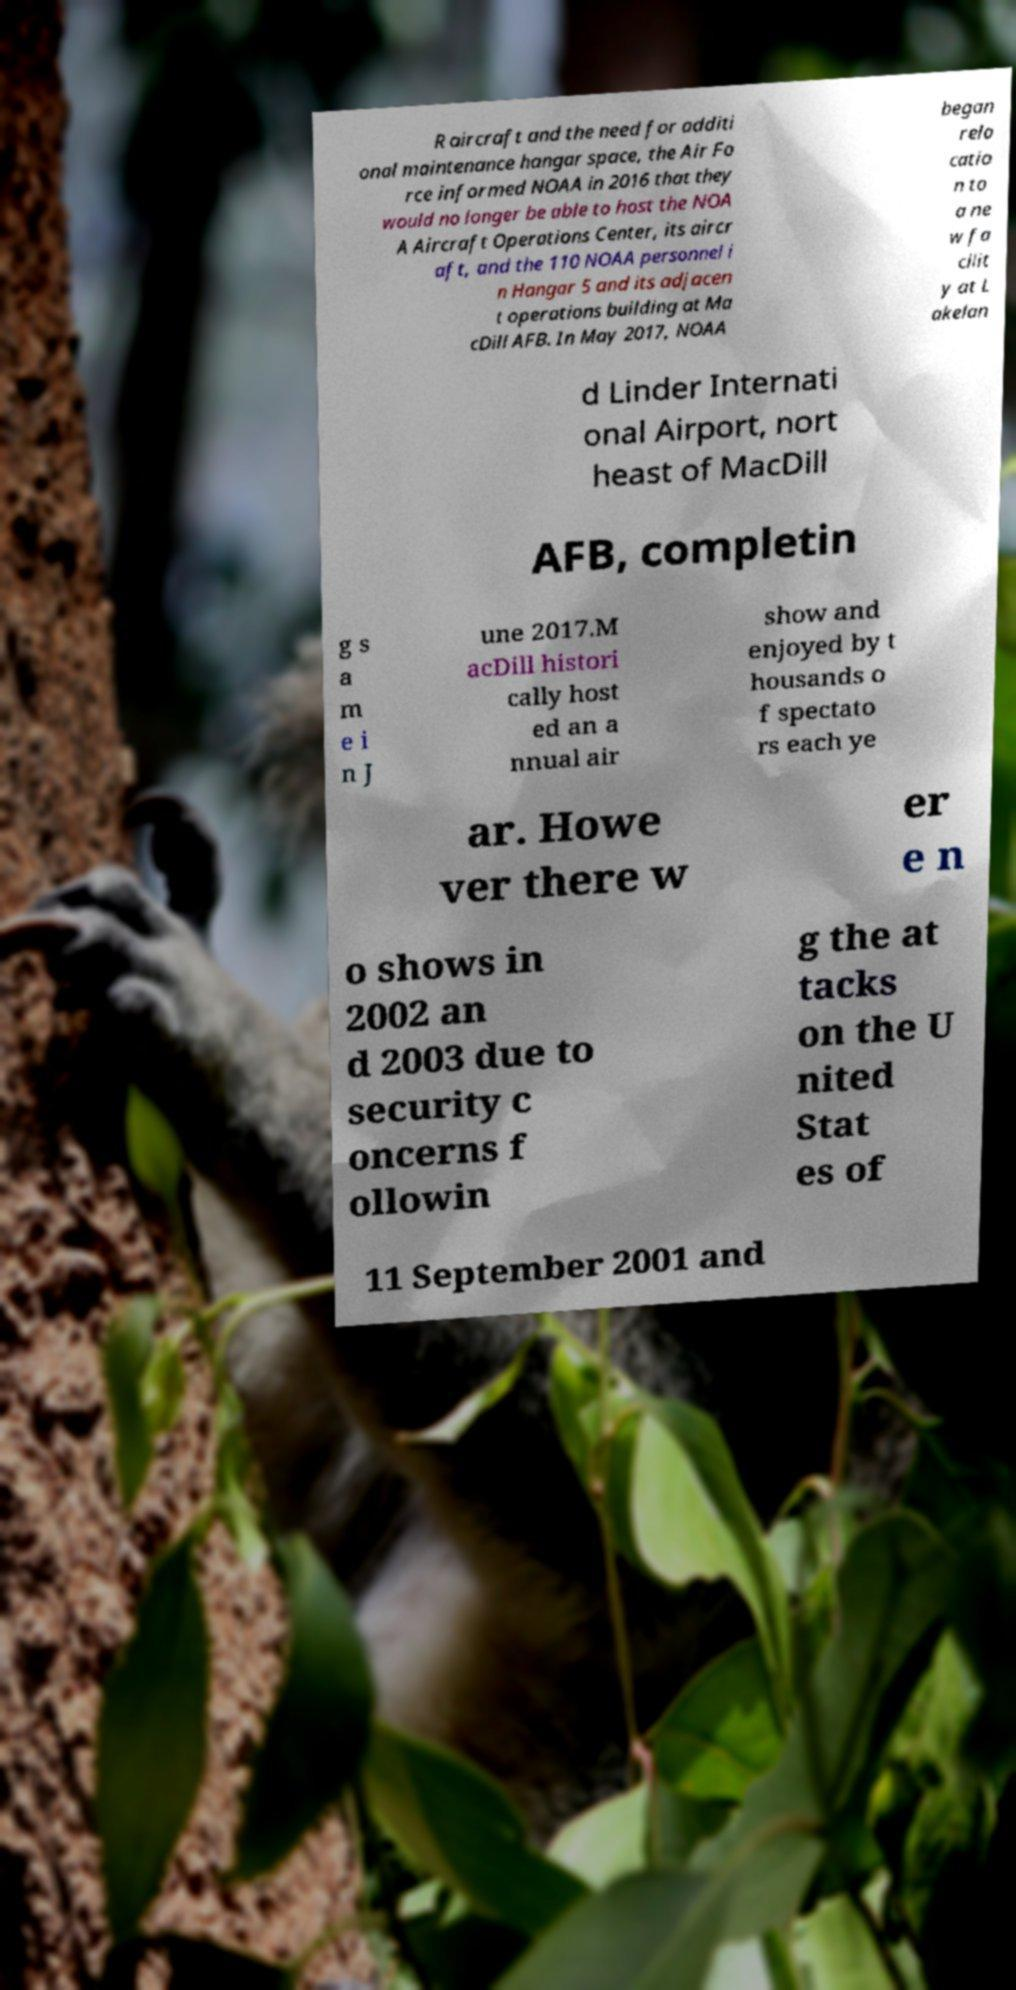Please identify and transcribe the text found in this image. R aircraft and the need for additi onal maintenance hangar space, the Air Fo rce informed NOAA in 2016 that they would no longer be able to host the NOA A Aircraft Operations Center, its aircr aft, and the 110 NOAA personnel i n Hangar 5 and its adjacen t operations building at Ma cDill AFB. In May 2017, NOAA began relo catio n to a ne w fa cilit y at L akelan d Linder Internati onal Airport, nort heast of MacDill AFB, completin g s a m e i n J une 2017.M acDill histori cally host ed an a nnual air show and enjoyed by t housands o f spectato rs each ye ar. Howe ver there w er e n o shows in 2002 an d 2003 due to security c oncerns f ollowin g the at tacks on the U nited Stat es of 11 September 2001 and 